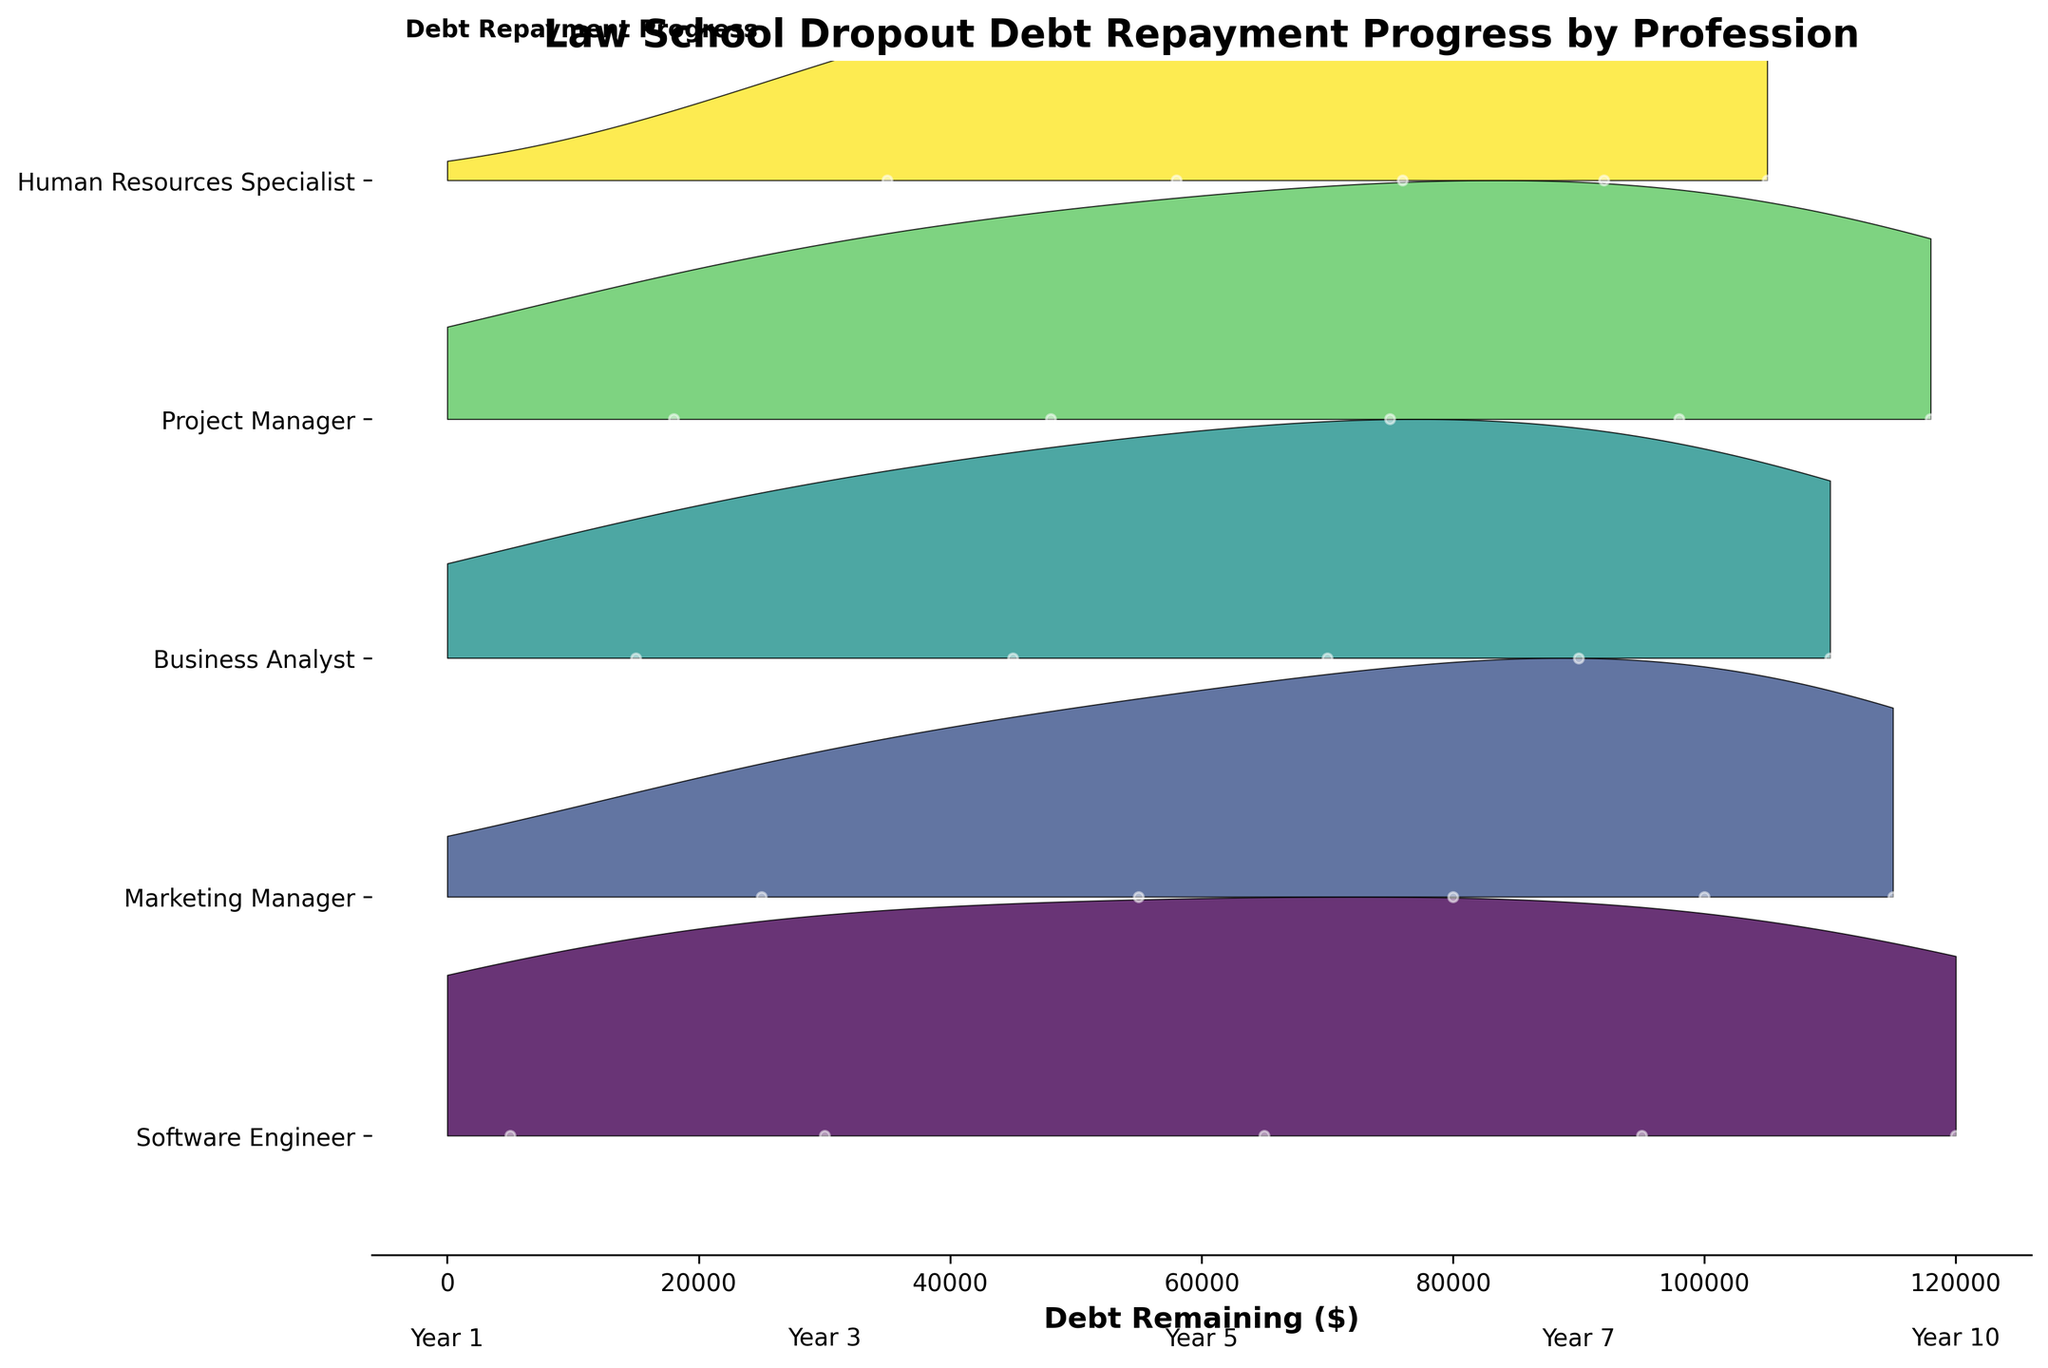What is the title of the figure? The title provides an overview of what the plot is about. It is typically found at the top center of the figure and gives context to the data being visualized.
Answer: Law School Dropout Debt Repayment Progress by Profession What does the x-axis represent in the plot? The x-axis is the horizontal axis of the figure, and it represents the variable being plotted against the professions, helping to interpret the data.
Answer: Debt Remaining ($) How many professions are represented in the ridgeline plot? The number of professions can be identified by counting distinct labels along the y-axis.
Answer: 5 Which profession shows the fastest debt repayment over the years? By comparing the progress of each profession over the various years regarding the amount of debt remaining, the profession with the steepest decline in debt over the years indicates the fastest repayment. For example, identify the profession whose ridgeline drops the quickest from left to right across the years.
Answer: Software Engineer Between Marketing Manager and Project Manager, which one has more debt remaining at year 5? Compare the ridgelines of Marketing Manager and Project Manager at the 5-year mark and identify which one has a higher debt remaining point on the x-axis.
Answer: Marketing Manager By year 10, which profession has the highest amount of debt remaining? Examine the ridgeline plot for each profession where the label is 'year 10' and determine which has the highest debt remaining value on the x-axis.
Answer: Human Resources Specialist What is the difference in debt remaining between Marketing Managers and Software Engineers at year 7? Locate the points representing the debt remaining for both professions at year 7. Subtract the debt remaining value of Software Engineers from that of Marketing Managers to find the difference.
Answer: 25000 Which profession shows the slowest debt repayment progress? Identify the profession whose ridgeline plots show the least change (least decrease in debt) over the years, indicating slower repayment progress.
Answer: Human Resources Specialist For which profession do the data points show the highest spread at year 3? By observing the plot, check the distribution or spread of the points for each profession at year 3 and identify where the data points are most dispersed.
Answer: Project Manager What is a common trend you observe among all professions regarding debt repayment over the years? Look for a general pattern in all the ridgelines across the plot, for example, whether all professions show a decreasing trend in debt remaining, indicating repayment over the years.
Answer: Decreasing debt over years 